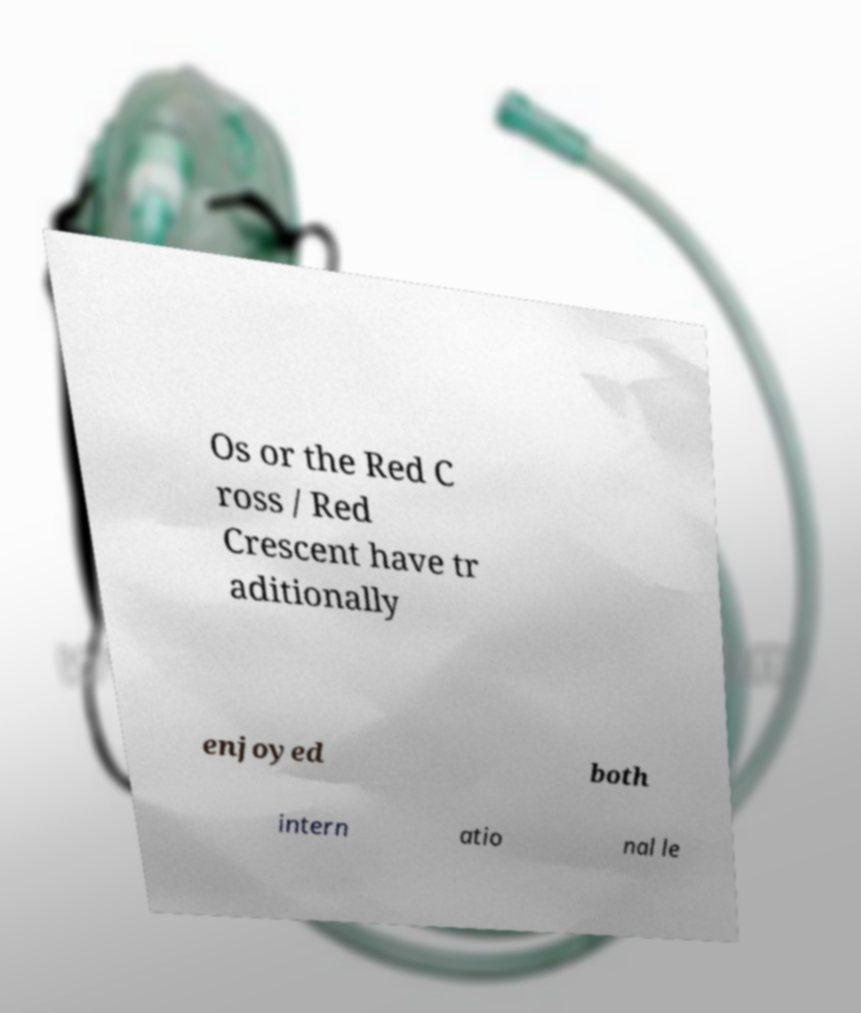Please identify and transcribe the text found in this image. Os or the Red C ross / Red Crescent have tr aditionally enjoyed both intern atio nal le 